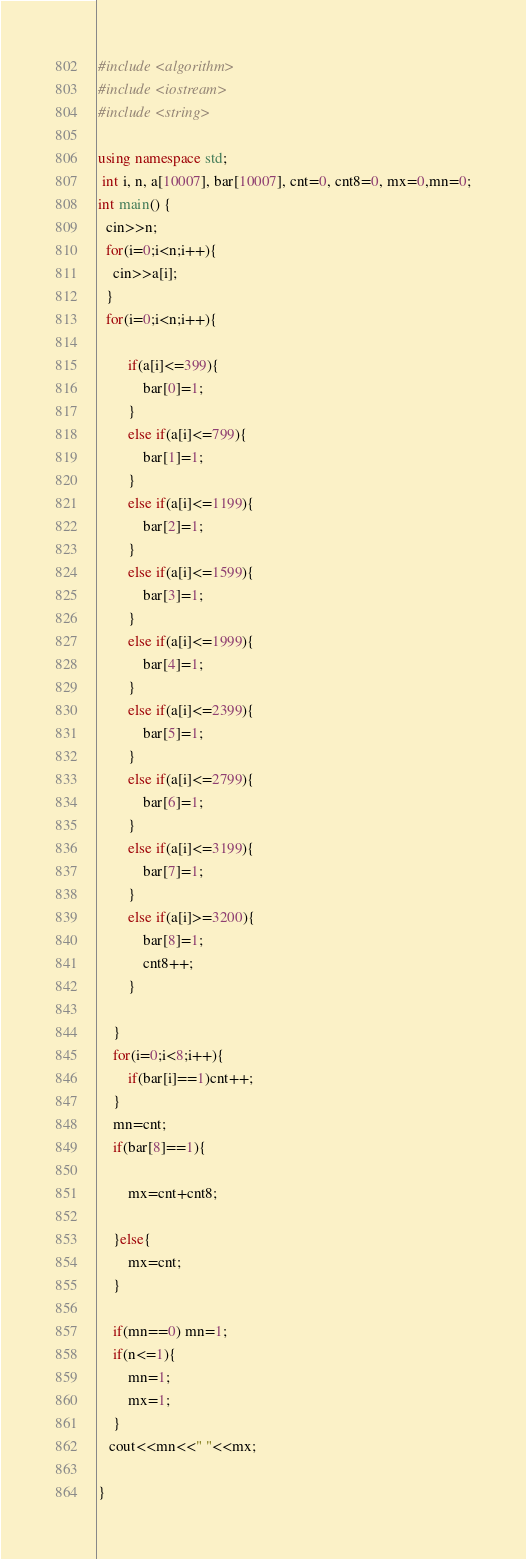<code> <loc_0><loc_0><loc_500><loc_500><_C++_>#include <algorithm>
#include <iostream>
#include <string>
 
using namespace std;
 int i, n, a[10007], bar[10007], cnt=0, cnt8=0, mx=0,mn=0;
int main() {
  cin>>n;
  for(i=0;i<n;i++){
  	cin>>a[i];
  }
  for(i=0;i<n;i++){
        
        if(a[i]<=399){
            bar[0]=1;
        }
		else if(a[i]<=799){
            bar[1]=1;
        }
		else if(a[i]<=1199){
            bar[2]=1;
        }
		else if(a[i]<=1599){
            bar[3]=1;
        }
		else if(a[i]<=1999){
            bar[4]=1;
        }
		else if(a[i]<=2399){
            bar[5]=1;
        }
		else if(a[i]<=2799){
            bar[6]=1;
        }
		else if(a[i]<=3199){
            bar[7]=1;
        }
		else if(a[i]>=3200){
            bar[8]=1;
            cnt8++;
        }
        
    }
  	for(i=0;i<8;i++){
        if(bar[i]==1)cnt++;
    }
    mn=cnt;
    if(bar[8]==1){

        mx=cnt+cnt8;

    }else{
        mx=cnt;
    }
    
    if(mn==0) mn=1;
    if(n<=1){
        mn=1;
        mx=1;
    }
   cout<<mn<<" "<<mx;
  
}</code> 